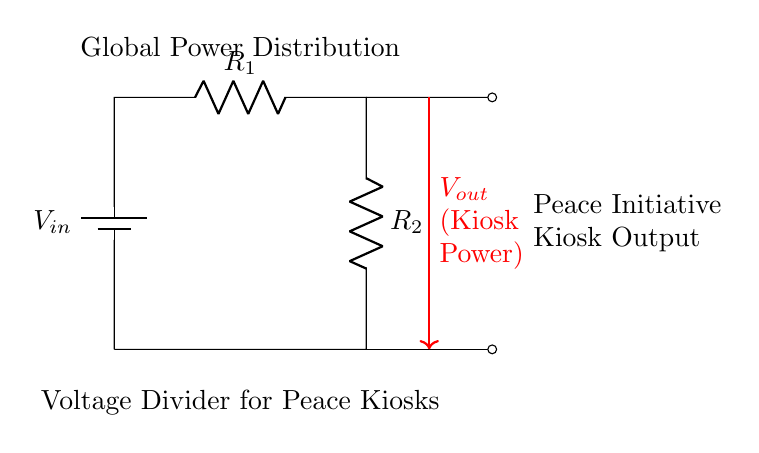What is the input voltage of the circuit? The input voltage is indicated at the battery in the circuit diagram, labeled as \( V_{in} \). It is typically the voltage provided to the circuit.
Answer: \( V_{in} \) What are the two resistors in the circuit? The circuit diagram shows two resistors labeled \( R_1 \) and \( R_2 \). They form part of the voltage divider arrangement.
Answer: \( R_1 \) and \( R_2 \) What is the purpose of this circuit? The purpose of this circuit is to distribute power to peace initiative kiosks, as indicated in the annotations in the diagram.
Answer: Power distribution What is the output voltage in relation to the resistors? The output voltage \( V_{out} \) is derived from the voltage across the resistor \( R_2 \) in this voltage divider configuration, based on the ratio of the resistors.
Answer: \( V_{out} \) How is the output voltage calculated? The output voltage is calculated using the voltage divider formula, which states that \( V_{out} = V_{in} \times \frac{R_2}{R_1 + R_2} \). This formula shows how the resistors divide the input voltage.
Answer: \( V_{out} = V_{in} \times \frac{R_2}{R_1 + R_2} \) What does the arrow indicating \( V_{out} \) represent? The arrow showing \( V_{out} \) represents the point at which the output voltage is taken from the circuit, specifically across \( R_2 \).
Answer: Output voltage point What signifies the connection to the peace initiative kiosks? The note "Peace Initiative Kiosk Output" in the diagram signifies where the power from the voltage divider will be directed to the kiosks, highlighting its intended application.
Answer: Power connection to kiosks 